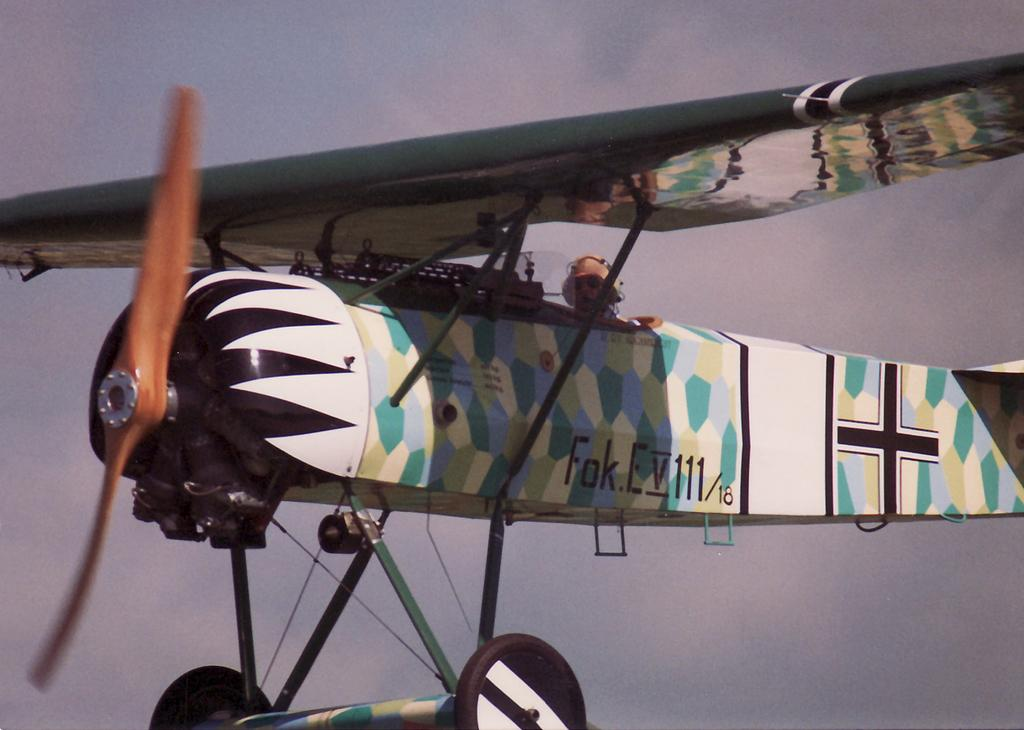What is the main subject in the foreground of the image? There is an airplane in the foreground of the image. What is the position of the airplane in the image? The airplane is in the air. Can you describe the person inside the airplane? There is a man inside the airplane. What can be seen in the background of the image? The sky is visible in the background of the image. What type of fork can be seen producing steam in the image? There is no fork or steam present in the image; it features an airplane with a man inside. 